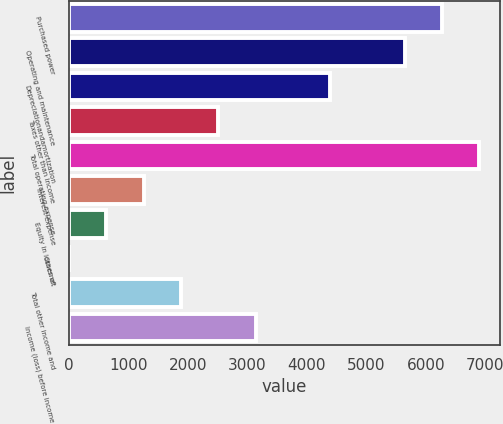<chart> <loc_0><loc_0><loc_500><loc_500><bar_chart><fcel>Purchased power<fcel>Operating and maintenance<fcel>Depreciationandamortization<fcel>Taxes other than income<fcel>Total operating expense<fcel>Interest expense<fcel>Equity in losses of<fcel>Othernet<fcel>Total other income and<fcel>Income (loss) before income<nl><fcel>6276<fcel>5649.2<fcel>4395.6<fcel>2515.2<fcel>6902.8<fcel>1261.6<fcel>634.8<fcel>8<fcel>1888.4<fcel>3142<nl></chart> 